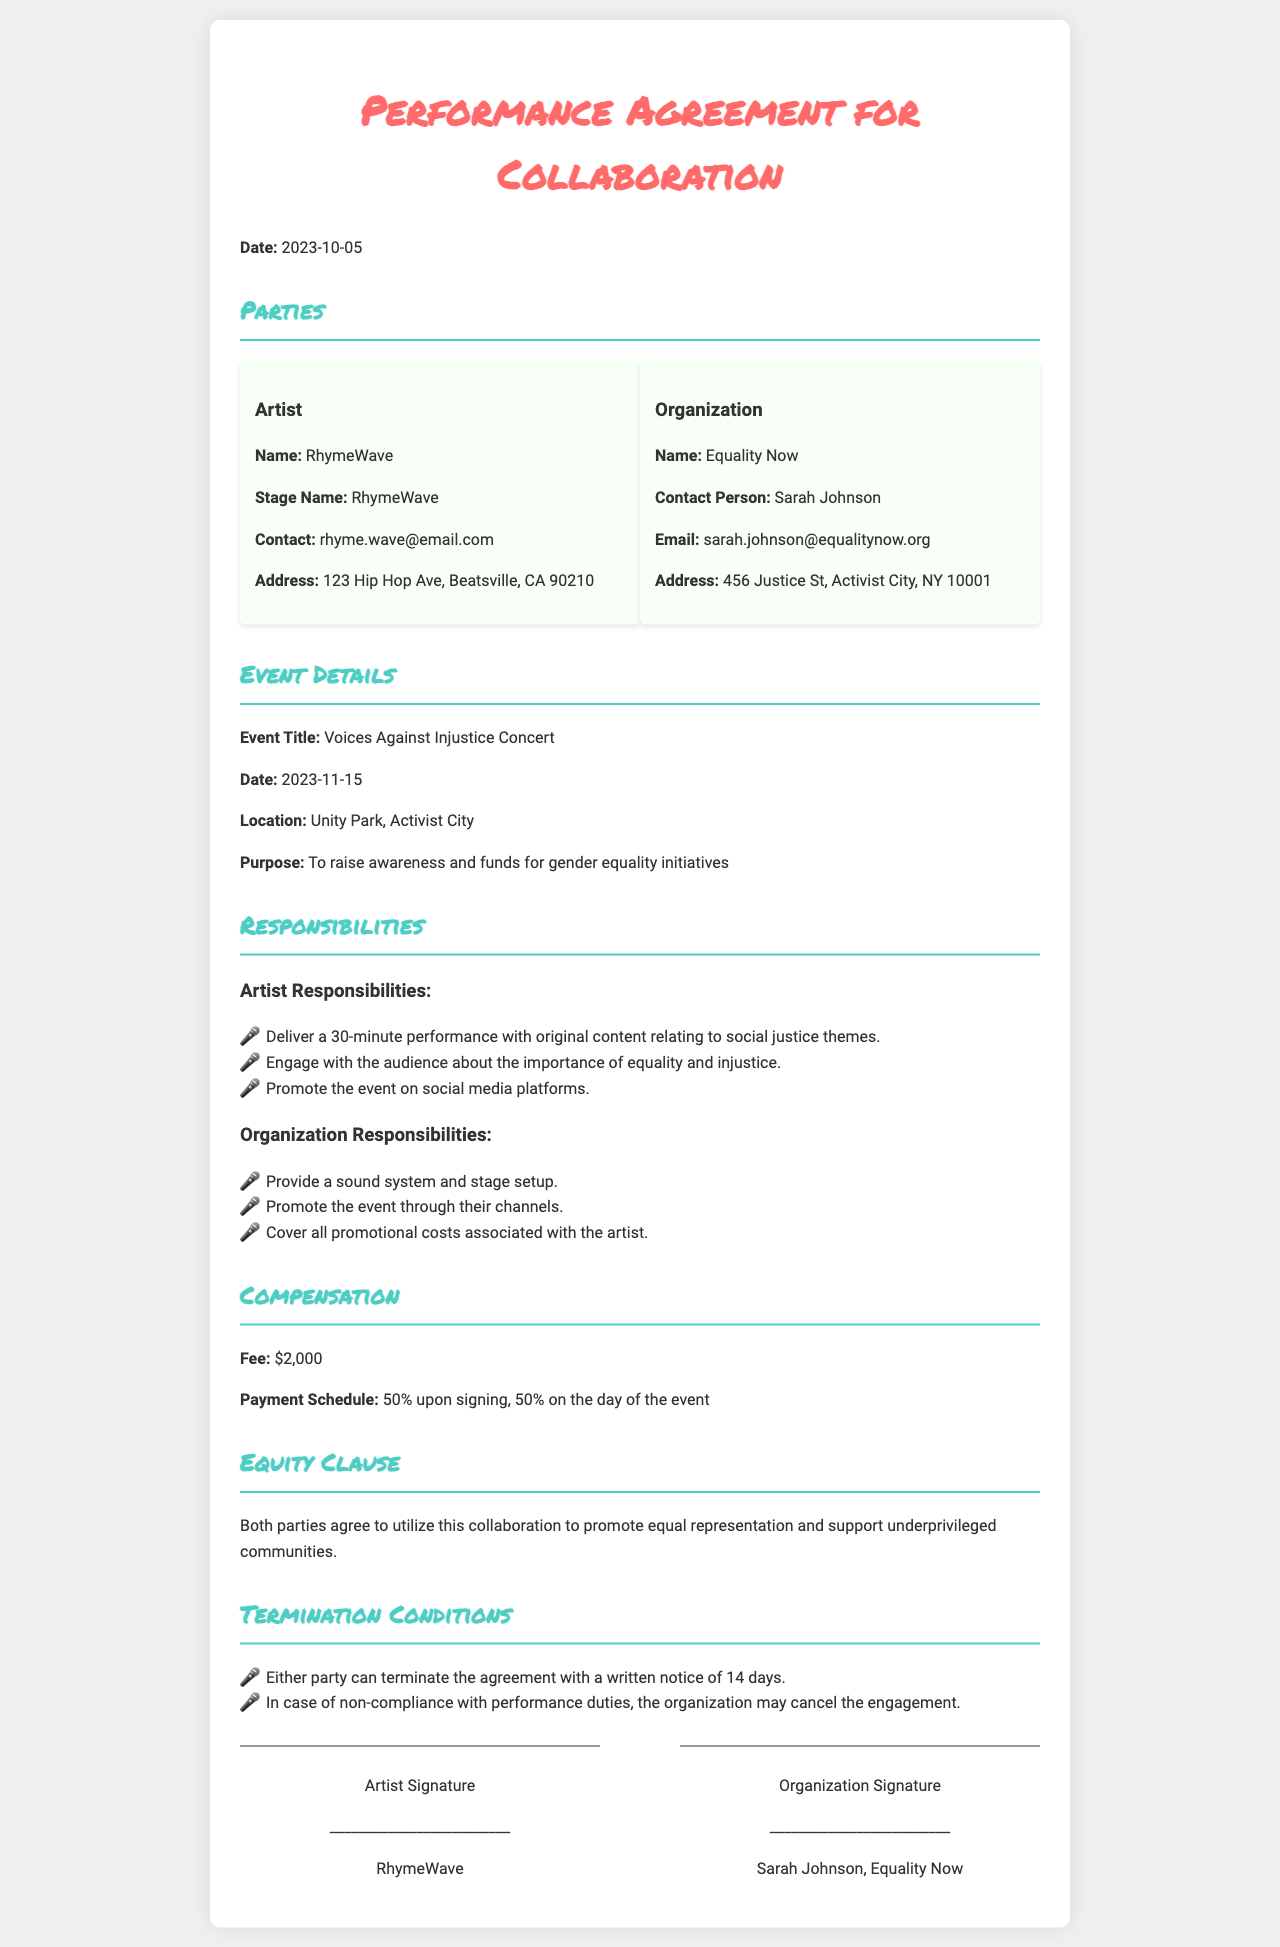What is the name of the artist? The artist's name is listed as RhymeWave in the document.
Answer: RhymeWave What is the date of the event? The event date is provided in the document as November 15, 2023.
Answer: 2023-11-15 Who is the contact person for the organization? The contact person for the organization is mentioned as Sarah Johnson.
Answer: Sarah Johnson What is the purpose of the event? The purpose of the event is to raise awareness and funds for gender equality initiatives.
Answer: To raise awareness and funds for gender equality initiatives What percentage of the payment is due upon signing? The agreement states that 50% of the payment is due upon signing.
Answer: 50% What is the venue for the event? The location of the event is specified as Unity Park, Activist City.
Answer: Unity Park, Activist City What is the total fee for the artist? The total fee agreed upon for the artist is $2,000 according to the document.
Answer: $2,000 What type of responsibilities does the artist have? The artist is responsible for delivering a 30-minute performance and engaging with the audience on social justice themes.
Answer: Deliver a 30-minute performance with original content relating to social justice themes 